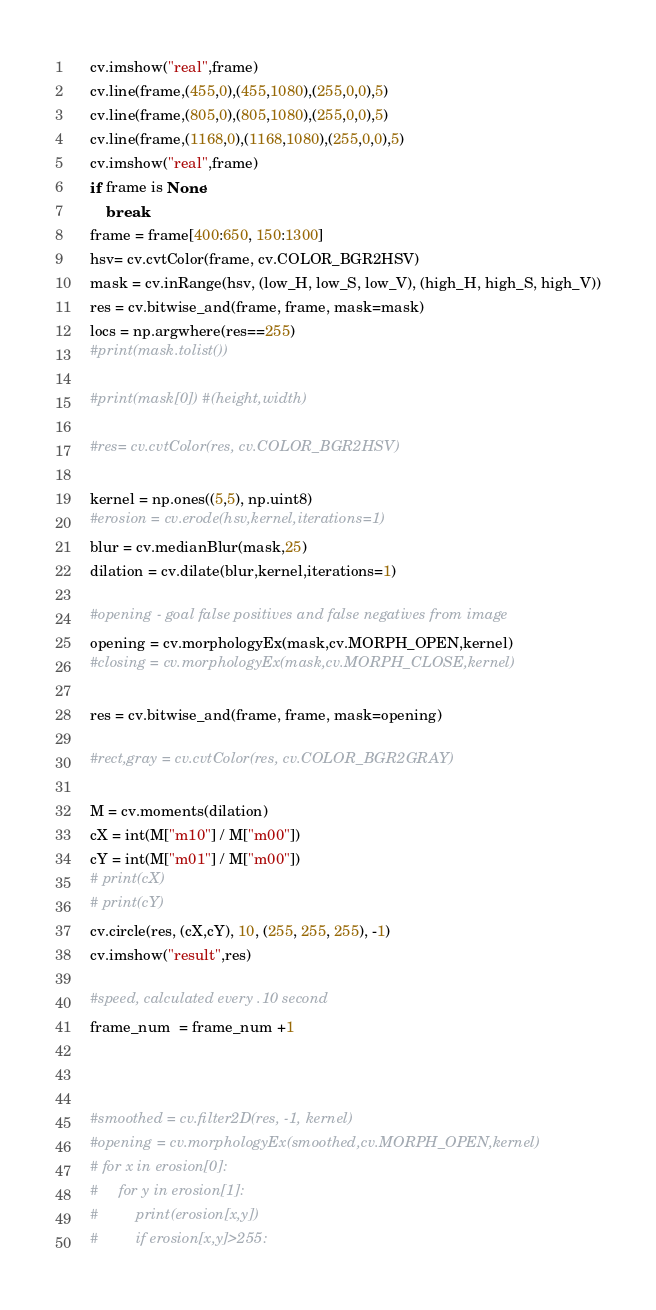<code> <loc_0><loc_0><loc_500><loc_500><_Python_>    cv.imshow("real",frame)
    cv.line(frame,(455,0),(455,1080),(255,0,0),5)
    cv.line(frame,(805,0),(805,1080),(255,0,0),5)
    cv.line(frame,(1168,0),(1168,1080),(255,0,0),5)
    cv.imshow("real",frame)
    if frame is None:
        break
    frame = frame[400:650, 150:1300]
    hsv= cv.cvtColor(frame, cv.COLOR_BGR2HSV)
    mask = cv.inRange(hsv, (low_H, low_S, low_V), (high_H, high_S, high_V))
    res = cv.bitwise_and(frame, frame, mask=mask)
    locs = np.argwhere(res==255)
    #print(mask.tolist())
    
    #print(mask[0]) #(height,width)

    #res= cv.cvtColor(res, cv.COLOR_BGR2HSV)

    kernel = np.ones((5,5), np.uint8)
    #erosion = cv.erode(hsv,kernel,iterations=1)
    blur = cv.medianBlur(mask,25)
    dilation = cv.dilate(blur,kernel,iterations=1)

    #opening - goal false positives and false negatives from image
    opening = cv.morphologyEx(mask,cv.MORPH_OPEN,kernel)
    #closing = cv.morphologyEx(mask,cv.MORPH_CLOSE,kernel)
    
    res = cv.bitwise_and(frame, frame, mask=opening)

    #rect,gray = cv.cvtColor(res, cv.COLOR_BGR2GRAY)
    
    M = cv.moments(dilation)
    cX = int(M["m10"] / M["m00"])
    cY = int(M["m01"] / M["m00"])
    # print(cX)
    # print(cY)
    cv.circle(res, (cX,cY), 10, (255, 255, 255), -1)
    cv.imshow("result",res)

    #speed, calculated every .10 second
    frame_num  = frame_num +1



    #smoothed = cv.filter2D(res, -1, kernel)
    #opening = cv.morphologyEx(smoothed,cv.MORPH_OPEN,kernel)
    # for x in erosion[0]:
    #     for y in erosion[1]:
    #         print(erosion[x,y])
    #         if erosion[x,y]>255:</code> 